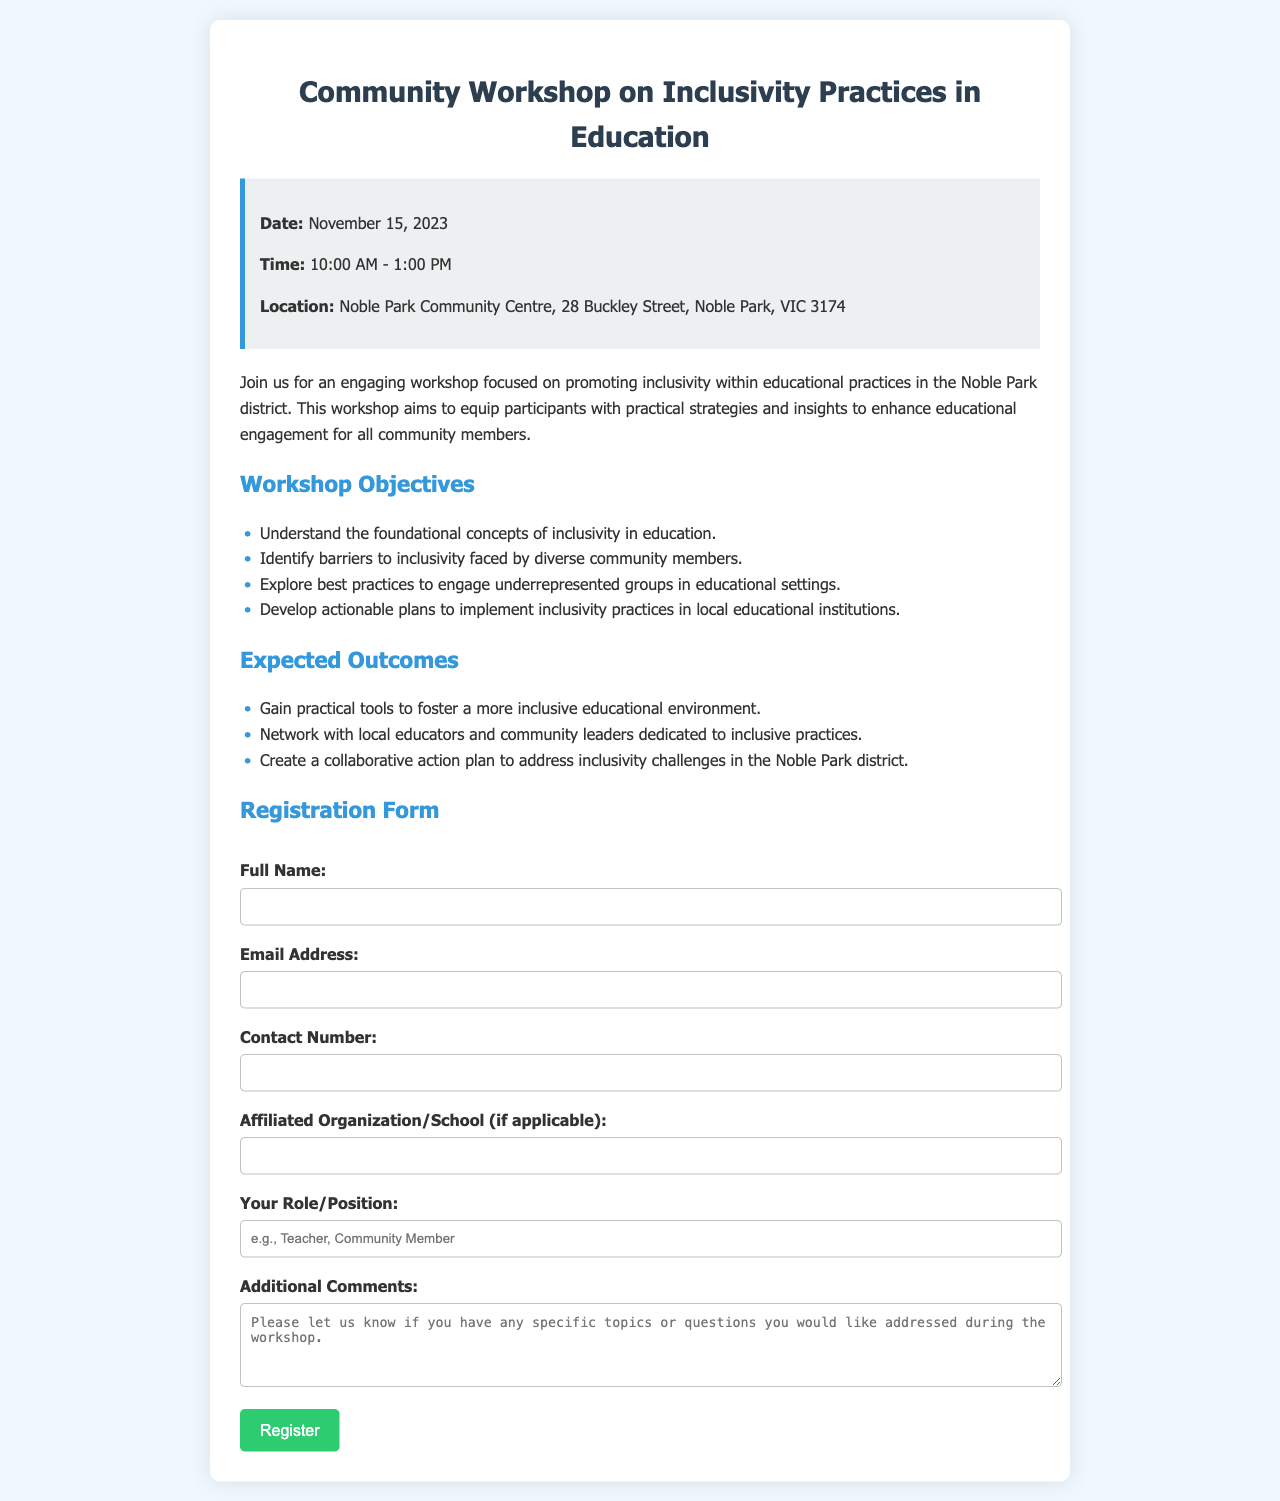What is the date of the workshop? The date of the workshop is explicitly stated in the document as November 15, 2023.
Answer: November 15, 2023 What is the location of the workshop? The location of the workshop is provided in the document as Noble Park Community Centre, 28 Buckley Street, Noble Park, VIC 3174.
Answer: Noble Park Community Centre, 28 Buckley Street, Noble Park, VIC 3174 What are the workshop hours? The document specifies that the workshop runs from 10:00 AM to 1:00 PM.
Answer: 10:00 AM - 1:00 PM What is one expected outcome of the workshop? The document lists several expected outcomes, one of which is gaining practical tools to foster a more inclusive educational environment.
Answer: Gain practical tools to foster a more inclusive educational environment What roles are participants encouraged to provide? The document requests participants to indicate their role or position, providing an example as Teacher or Community Member.
Answer: Teacher, Community Member How many objectives are listed for the workshop? The document outlines four objectives that the workshop aims to achieve.
Answer: 4 What type of feedback can participants provide in the registration form? The registration form includes an option for participants to leave additional comments, specifying topics or questions they'd like addressed.
Answer: Additional comments What type of organization might participants list in the form? Participants are prompted to provide their affiliated organization or school, if applicable.
Answer: Affiliated Organization/School What style of educational practices is the workshop promoting? The workshop promotes inclusivity practices in education, as stated in the title and content.
Answer: Inclusivity practices in education 